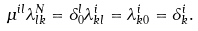Convert formula to latex. <formula><loc_0><loc_0><loc_500><loc_500>\mu ^ { i l } \lambda ^ { N } _ { l k } = \delta ^ { l } _ { 0 } \lambda ^ { i } _ { k l } = \lambda ^ { i } _ { k 0 } = \delta ^ { i } _ { k } .</formula> 